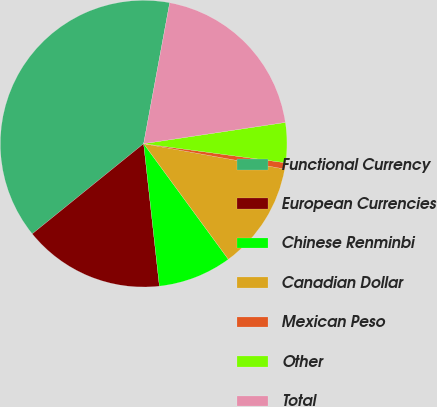Convert chart to OTSL. <chart><loc_0><loc_0><loc_500><loc_500><pie_chart><fcel>Functional Currency<fcel>European Currencies<fcel>Chinese Renminbi<fcel>Canadian Dollar<fcel>Mexican Peso<fcel>Other<fcel>Total<nl><fcel>38.74%<fcel>15.92%<fcel>8.31%<fcel>12.11%<fcel>0.7%<fcel>4.5%<fcel>19.72%<nl></chart> 